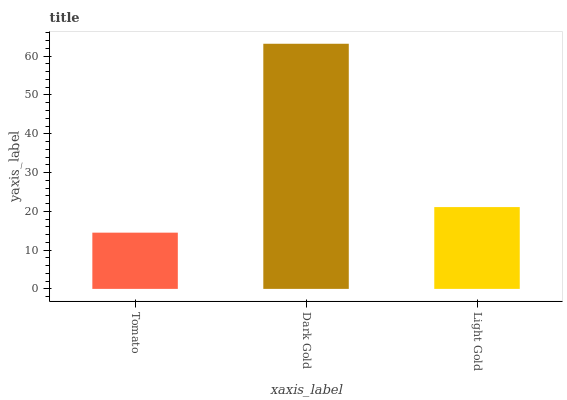Is Tomato the minimum?
Answer yes or no. Yes. Is Dark Gold the maximum?
Answer yes or no. Yes. Is Light Gold the minimum?
Answer yes or no. No. Is Light Gold the maximum?
Answer yes or no. No. Is Dark Gold greater than Light Gold?
Answer yes or no. Yes. Is Light Gold less than Dark Gold?
Answer yes or no. Yes. Is Light Gold greater than Dark Gold?
Answer yes or no. No. Is Dark Gold less than Light Gold?
Answer yes or no. No. Is Light Gold the high median?
Answer yes or no. Yes. Is Light Gold the low median?
Answer yes or no. Yes. Is Dark Gold the high median?
Answer yes or no. No. Is Tomato the low median?
Answer yes or no. No. 